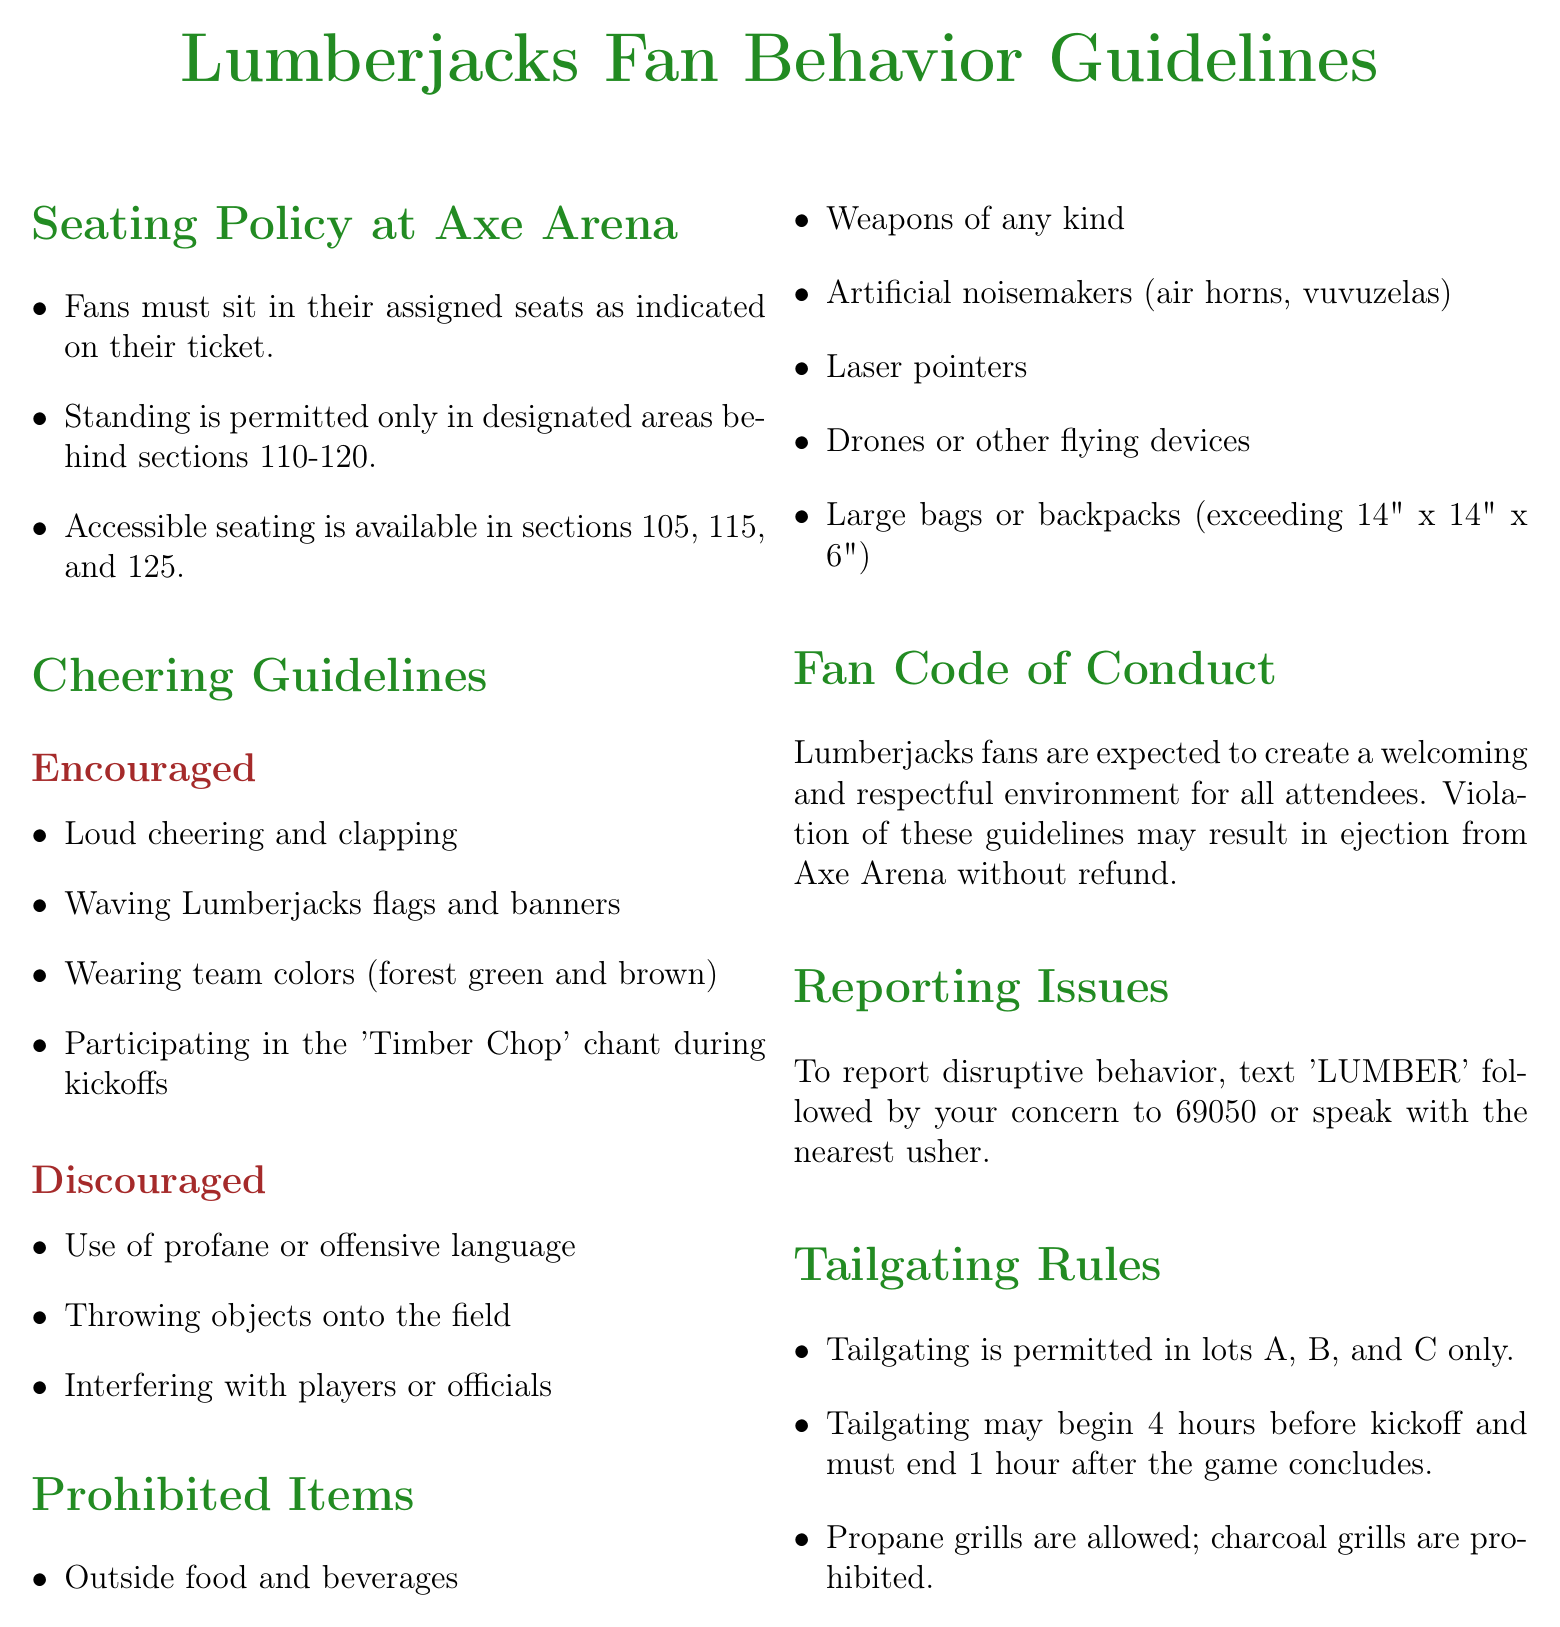What sections have accessible seating? Accessible seating is available in sections 105, 115, and 125 as mentioned in the seating policy.
Answer: 105, 115, 125 What must fans do regarding their assigned seats? Fans must sit in their assigned seats as indicated on their ticket according to the seating policy.
Answer: Sit in assigned seats What items are fans discouraged from throwing? The document states that throwing objects onto the field is discouraged in the cheering guidelines.
Answer: Objects onto the field Where can tailgating take place? Tailgating is permitted in lots A, B, and C only as per the tailgating rules.
Answer: Lots A, B, C What is the penalty for violating fan guidelines? Violation of these guidelines may result in ejection from Axe Arena without refund as stated in the fan code of conduct.
Answer: Ejection without refund What is the color scheme fans are encouraged to wear? The document encourages fans to wear team colors, which are forest green and brown.
Answer: Forest green and brown What is the maximum allowed size for bags? The maximum dimensions for bags permitted are specified as exceeding 14" x 14" x 6" in the prohibited items section.
Answer: 14" x 14" x 6" How can disruptive behavior be reported? To report disruptive behavior, fans can text 'LUMBER' followed by their concern to 69050 or speak with the nearest usher as per the reporting issues section.
Answer: Text 'LUMBER' to 69050 What type of grills are prohibited for tailgating? The document states that charcoal grills are prohibited according to the tailgating rules.
Answer: Charcoal grills 